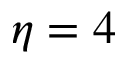<formula> <loc_0><loc_0><loc_500><loc_500>\eta = 4</formula> 